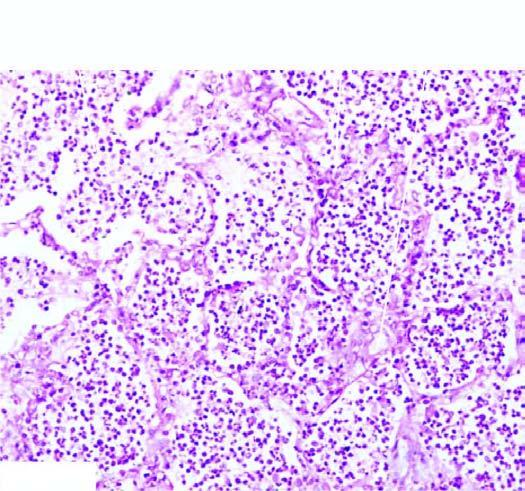what are the alveoli filled with?
Answer the question using a single word or phrase. Cellular exudates composed of neutrophils admixed some red cells 